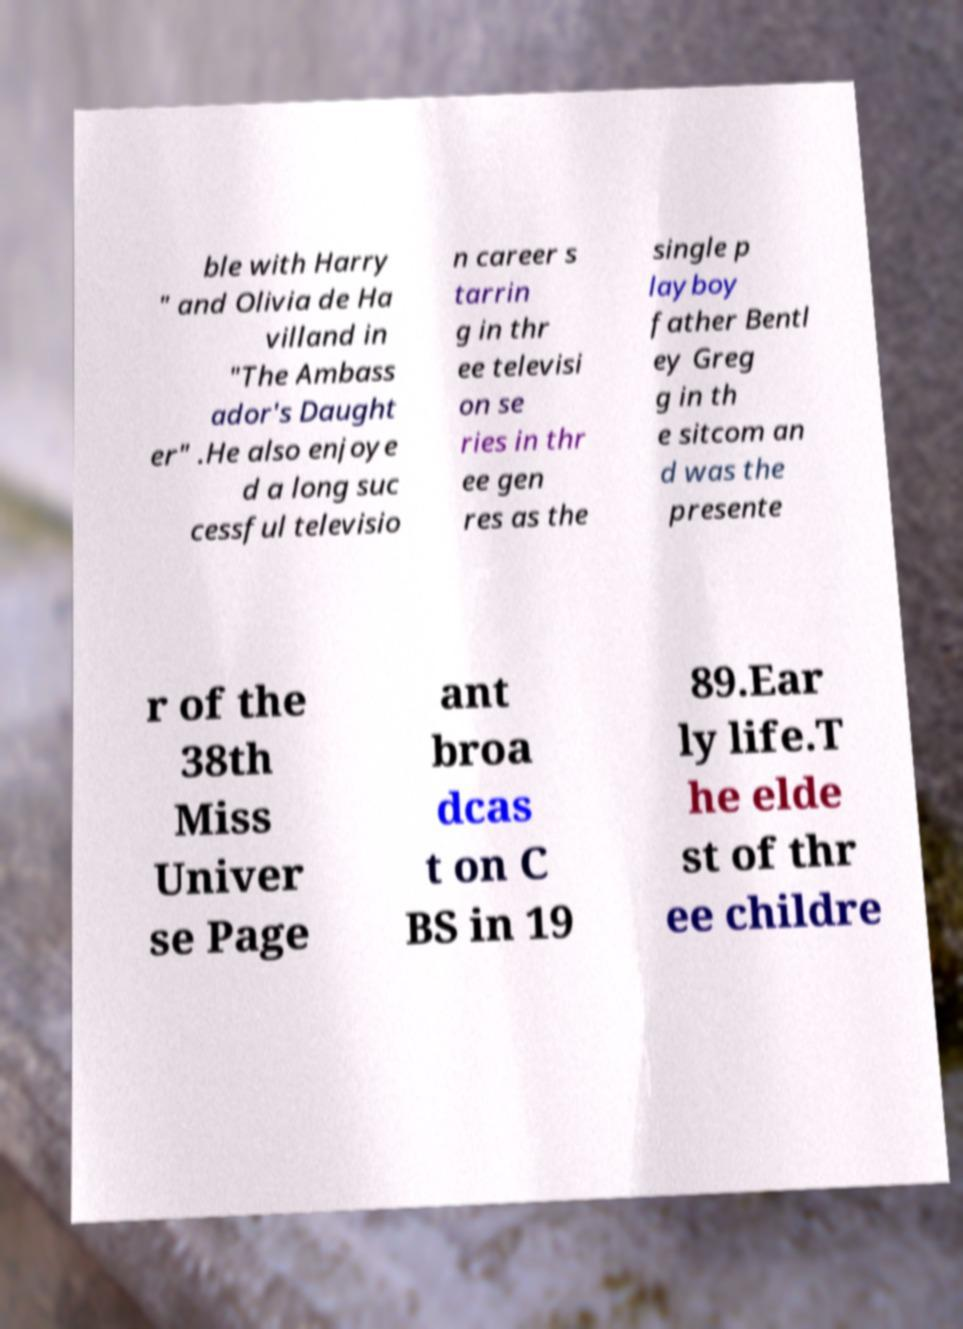Could you assist in decoding the text presented in this image and type it out clearly? ble with Harry " and Olivia de Ha villand in "The Ambass ador's Daught er" .He also enjoye d a long suc cessful televisio n career s tarrin g in thr ee televisi on se ries in thr ee gen res as the single p layboy father Bentl ey Greg g in th e sitcom an d was the presente r of the 38th Miss Univer se Page ant broa dcas t on C BS in 19 89.Ear ly life.T he elde st of thr ee childre 